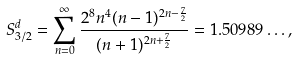Convert formula to latex. <formula><loc_0><loc_0><loc_500><loc_500>S _ { 3 / 2 } ^ { d } = \sum _ { n = 0 } ^ { \infty } \frac { 2 ^ { 8 } n ^ { 4 } ( n - 1 ) ^ { 2 n - \frac { 7 } { 2 } } } { ( n + 1 ) ^ { 2 n + \frac { 7 } { 2 } } } = 1 . 5 0 9 8 9 \dots ,</formula> 